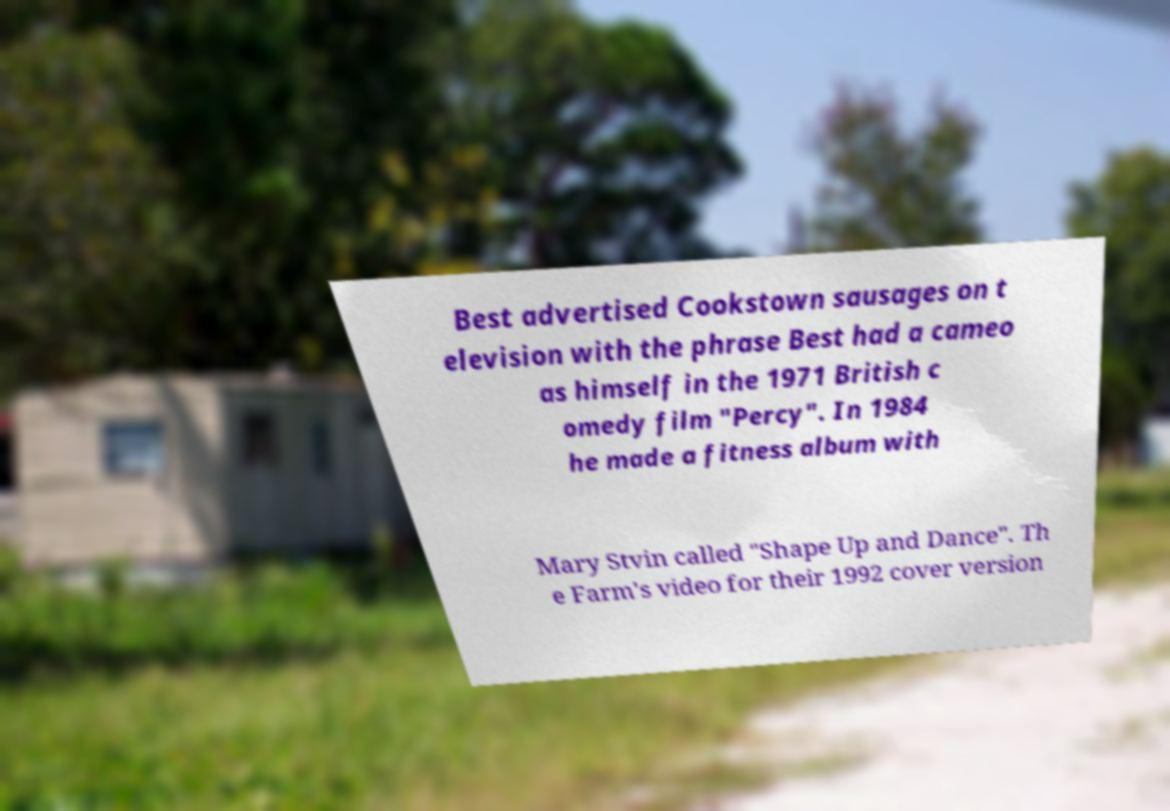Could you extract and type out the text from this image? Best advertised Cookstown sausages on t elevision with the phrase Best had a cameo as himself in the 1971 British c omedy film "Percy". In 1984 he made a fitness album with Mary Stvin called "Shape Up and Dance". Th e Farm's video for their 1992 cover version 